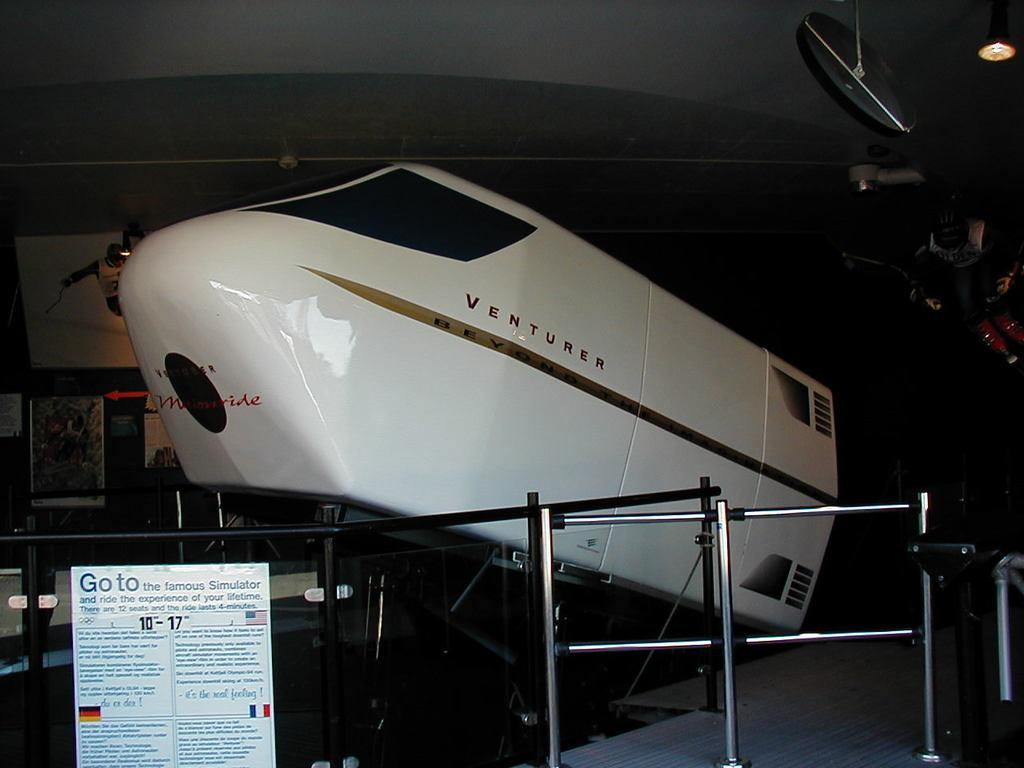<image>
Write a terse but informative summary of the picture. a space shuttle with the word Venturer on the side 